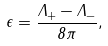Convert formula to latex. <formula><loc_0><loc_0><loc_500><loc_500>\epsilon = \frac { \Lambda _ { + } - \Lambda _ { - } } { 8 \pi } ,</formula> 